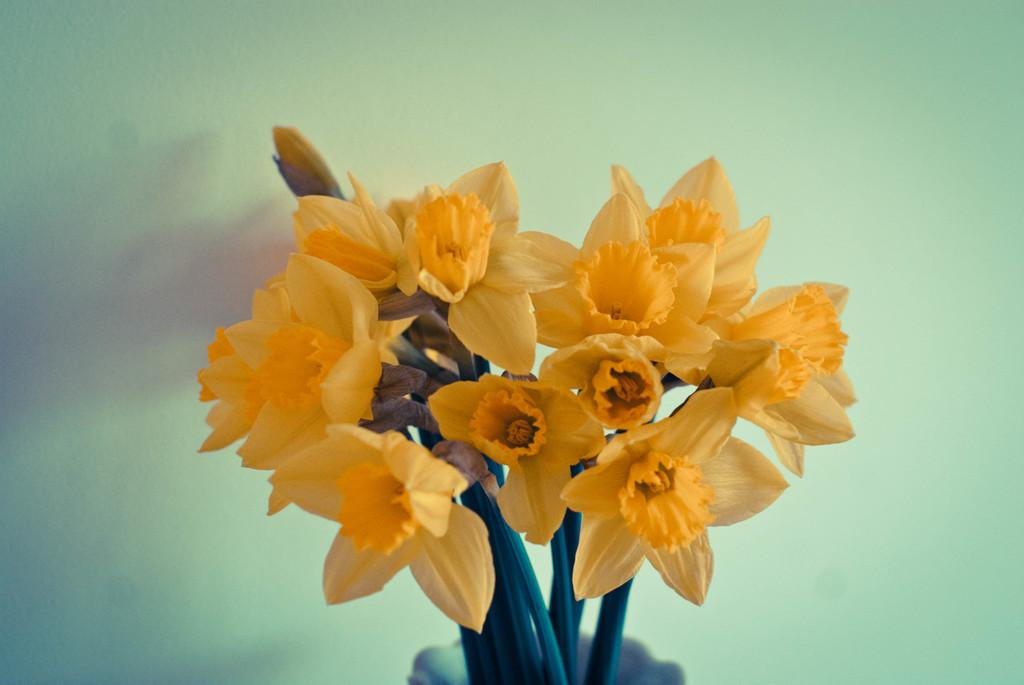What type of plants are in the image? There are flowers in the image. How are the flowers arranged or displayed? The flowers are in a vase. What color is the background of the image? The background of the image is white. What type of owl can be seen perched on the tree in the image? There is no owl or tree present in the image; it features flowers in a vase against a white background. 